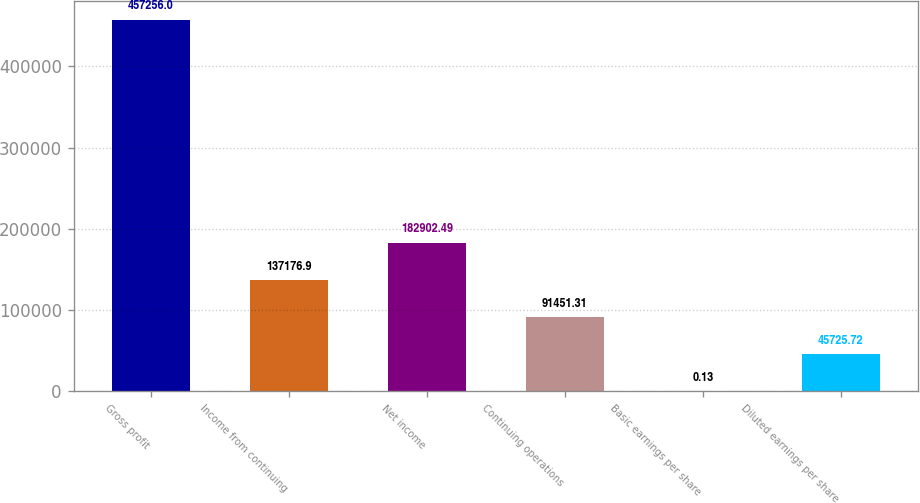Convert chart. <chart><loc_0><loc_0><loc_500><loc_500><bar_chart><fcel>Gross profit<fcel>Income from continuing<fcel>Net income<fcel>Continuing operations<fcel>Basic earnings per share<fcel>Diluted earnings per share<nl><fcel>457256<fcel>137177<fcel>182902<fcel>91451.3<fcel>0.13<fcel>45725.7<nl></chart> 